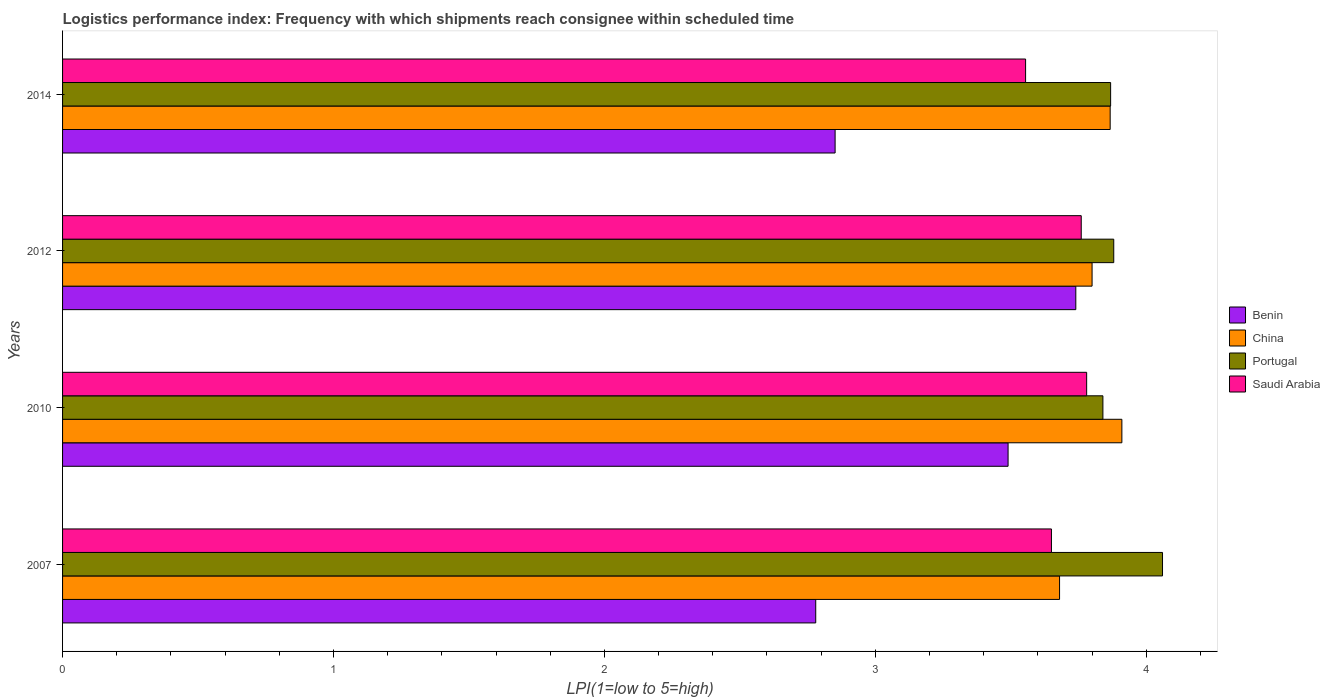How many different coloured bars are there?
Offer a terse response. 4. Are the number of bars per tick equal to the number of legend labels?
Keep it short and to the point. Yes. Are the number of bars on each tick of the Y-axis equal?
Give a very brief answer. Yes. What is the label of the 4th group of bars from the top?
Give a very brief answer. 2007. What is the logistics performance index in Benin in 2012?
Ensure brevity in your answer.  3.74. Across all years, what is the maximum logistics performance index in China?
Offer a very short reply. 3.91. Across all years, what is the minimum logistics performance index in Portugal?
Offer a terse response. 3.84. In which year was the logistics performance index in Portugal maximum?
Your answer should be very brief. 2007. In which year was the logistics performance index in Saudi Arabia minimum?
Your answer should be very brief. 2014. What is the total logistics performance index in Benin in the graph?
Give a very brief answer. 12.86. What is the difference between the logistics performance index in China in 2007 and that in 2014?
Your response must be concise. -0.19. What is the difference between the logistics performance index in Benin in 2010 and the logistics performance index in Saudi Arabia in 2014?
Keep it short and to the point. -0.06. What is the average logistics performance index in Saudi Arabia per year?
Make the answer very short. 3.69. In the year 2010, what is the difference between the logistics performance index in Benin and logistics performance index in Portugal?
Your answer should be very brief. -0.35. In how many years, is the logistics performance index in Benin greater than 1.2 ?
Provide a succinct answer. 4. What is the ratio of the logistics performance index in Saudi Arabia in 2007 to that in 2014?
Offer a terse response. 1.03. Is the logistics performance index in Saudi Arabia in 2010 less than that in 2014?
Offer a very short reply. No. Is the difference between the logistics performance index in Benin in 2010 and 2014 greater than the difference between the logistics performance index in Portugal in 2010 and 2014?
Your response must be concise. Yes. What is the difference between the highest and the second highest logistics performance index in Benin?
Make the answer very short. 0.25. What is the difference between the highest and the lowest logistics performance index in China?
Make the answer very short. 0.23. In how many years, is the logistics performance index in Portugal greater than the average logistics performance index in Portugal taken over all years?
Make the answer very short. 1. What does the 1st bar from the top in 2010 represents?
Your answer should be very brief. Saudi Arabia. What does the 3rd bar from the bottom in 2007 represents?
Make the answer very short. Portugal. How many bars are there?
Offer a terse response. 16. How many years are there in the graph?
Offer a terse response. 4. What is the title of the graph?
Give a very brief answer. Logistics performance index: Frequency with which shipments reach consignee within scheduled time. Does "Estonia" appear as one of the legend labels in the graph?
Your response must be concise. No. What is the label or title of the X-axis?
Give a very brief answer. LPI(1=low to 5=high). What is the label or title of the Y-axis?
Your answer should be compact. Years. What is the LPI(1=low to 5=high) of Benin in 2007?
Offer a terse response. 2.78. What is the LPI(1=low to 5=high) of China in 2007?
Your answer should be very brief. 3.68. What is the LPI(1=low to 5=high) in Portugal in 2007?
Your answer should be very brief. 4.06. What is the LPI(1=low to 5=high) of Saudi Arabia in 2007?
Your answer should be compact. 3.65. What is the LPI(1=low to 5=high) of Benin in 2010?
Provide a succinct answer. 3.49. What is the LPI(1=low to 5=high) in China in 2010?
Ensure brevity in your answer.  3.91. What is the LPI(1=low to 5=high) in Portugal in 2010?
Your answer should be very brief. 3.84. What is the LPI(1=low to 5=high) in Saudi Arabia in 2010?
Provide a succinct answer. 3.78. What is the LPI(1=low to 5=high) of Benin in 2012?
Your response must be concise. 3.74. What is the LPI(1=low to 5=high) of Portugal in 2012?
Give a very brief answer. 3.88. What is the LPI(1=low to 5=high) of Saudi Arabia in 2012?
Offer a terse response. 3.76. What is the LPI(1=low to 5=high) in Benin in 2014?
Keep it short and to the point. 2.85. What is the LPI(1=low to 5=high) in China in 2014?
Give a very brief answer. 3.87. What is the LPI(1=low to 5=high) in Portugal in 2014?
Your answer should be very brief. 3.87. What is the LPI(1=low to 5=high) in Saudi Arabia in 2014?
Your response must be concise. 3.55. Across all years, what is the maximum LPI(1=low to 5=high) of Benin?
Provide a short and direct response. 3.74. Across all years, what is the maximum LPI(1=low to 5=high) in China?
Your answer should be very brief. 3.91. Across all years, what is the maximum LPI(1=low to 5=high) in Portugal?
Your response must be concise. 4.06. Across all years, what is the maximum LPI(1=low to 5=high) in Saudi Arabia?
Ensure brevity in your answer.  3.78. Across all years, what is the minimum LPI(1=low to 5=high) of Benin?
Keep it short and to the point. 2.78. Across all years, what is the minimum LPI(1=low to 5=high) in China?
Offer a terse response. 3.68. Across all years, what is the minimum LPI(1=low to 5=high) of Portugal?
Your response must be concise. 3.84. Across all years, what is the minimum LPI(1=low to 5=high) of Saudi Arabia?
Offer a very short reply. 3.55. What is the total LPI(1=low to 5=high) in Benin in the graph?
Keep it short and to the point. 12.86. What is the total LPI(1=low to 5=high) of China in the graph?
Give a very brief answer. 15.26. What is the total LPI(1=low to 5=high) in Portugal in the graph?
Provide a short and direct response. 15.65. What is the total LPI(1=low to 5=high) of Saudi Arabia in the graph?
Your response must be concise. 14.74. What is the difference between the LPI(1=low to 5=high) in Benin in 2007 and that in 2010?
Provide a succinct answer. -0.71. What is the difference between the LPI(1=low to 5=high) in China in 2007 and that in 2010?
Ensure brevity in your answer.  -0.23. What is the difference between the LPI(1=low to 5=high) of Portugal in 2007 and that in 2010?
Provide a short and direct response. 0.22. What is the difference between the LPI(1=low to 5=high) in Saudi Arabia in 2007 and that in 2010?
Provide a short and direct response. -0.13. What is the difference between the LPI(1=low to 5=high) in Benin in 2007 and that in 2012?
Your response must be concise. -0.96. What is the difference between the LPI(1=low to 5=high) of China in 2007 and that in 2012?
Provide a succinct answer. -0.12. What is the difference between the LPI(1=low to 5=high) in Portugal in 2007 and that in 2012?
Keep it short and to the point. 0.18. What is the difference between the LPI(1=low to 5=high) of Saudi Arabia in 2007 and that in 2012?
Provide a succinct answer. -0.11. What is the difference between the LPI(1=low to 5=high) of Benin in 2007 and that in 2014?
Offer a terse response. -0.07. What is the difference between the LPI(1=low to 5=high) of China in 2007 and that in 2014?
Offer a very short reply. -0.19. What is the difference between the LPI(1=low to 5=high) of Portugal in 2007 and that in 2014?
Offer a very short reply. 0.19. What is the difference between the LPI(1=low to 5=high) in Saudi Arabia in 2007 and that in 2014?
Your answer should be very brief. 0.1. What is the difference between the LPI(1=low to 5=high) of Benin in 2010 and that in 2012?
Your response must be concise. -0.25. What is the difference between the LPI(1=low to 5=high) of China in 2010 and that in 2012?
Give a very brief answer. 0.11. What is the difference between the LPI(1=low to 5=high) in Portugal in 2010 and that in 2012?
Ensure brevity in your answer.  -0.04. What is the difference between the LPI(1=low to 5=high) of Benin in 2010 and that in 2014?
Your answer should be very brief. 0.64. What is the difference between the LPI(1=low to 5=high) of China in 2010 and that in 2014?
Make the answer very short. 0.04. What is the difference between the LPI(1=low to 5=high) of Portugal in 2010 and that in 2014?
Your response must be concise. -0.03. What is the difference between the LPI(1=low to 5=high) in Saudi Arabia in 2010 and that in 2014?
Provide a succinct answer. 0.23. What is the difference between the LPI(1=low to 5=high) of Benin in 2012 and that in 2014?
Ensure brevity in your answer.  0.89. What is the difference between the LPI(1=low to 5=high) in China in 2012 and that in 2014?
Make the answer very short. -0.07. What is the difference between the LPI(1=low to 5=high) in Portugal in 2012 and that in 2014?
Your answer should be compact. 0.01. What is the difference between the LPI(1=low to 5=high) of Saudi Arabia in 2012 and that in 2014?
Make the answer very short. 0.21. What is the difference between the LPI(1=low to 5=high) in Benin in 2007 and the LPI(1=low to 5=high) in China in 2010?
Provide a short and direct response. -1.13. What is the difference between the LPI(1=low to 5=high) in Benin in 2007 and the LPI(1=low to 5=high) in Portugal in 2010?
Offer a terse response. -1.06. What is the difference between the LPI(1=low to 5=high) of China in 2007 and the LPI(1=low to 5=high) of Portugal in 2010?
Your response must be concise. -0.16. What is the difference between the LPI(1=low to 5=high) of China in 2007 and the LPI(1=low to 5=high) of Saudi Arabia in 2010?
Offer a terse response. -0.1. What is the difference between the LPI(1=low to 5=high) of Portugal in 2007 and the LPI(1=low to 5=high) of Saudi Arabia in 2010?
Your response must be concise. 0.28. What is the difference between the LPI(1=low to 5=high) in Benin in 2007 and the LPI(1=low to 5=high) in China in 2012?
Ensure brevity in your answer.  -1.02. What is the difference between the LPI(1=low to 5=high) of Benin in 2007 and the LPI(1=low to 5=high) of Saudi Arabia in 2012?
Provide a succinct answer. -0.98. What is the difference between the LPI(1=low to 5=high) of China in 2007 and the LPI(1=low to 5=high) of Portugal in 2012?
Provide a short and direct response. -0.2. What is the difference between the LPI(1=low to 5=high) of China in 2007 and the LPI(1=low to 5=high) of Saudi Arabia in 2012?
Offer a terse response. -0.08. What is the difference between the LPI(1=low to 5=high) of Benin in 2007 and the LPI(1=low to 5=high) of China in 2014?
Give a very brief answer. -1.09. What is the difference between the LPI(1=low to 5=high) of Benin in 2007 and the LPI(1=low to 5=high) of Portugal in 2014?
Your response must be concise. -1.09. What is the difference between the LPI(1=low to 5=high) in Benin in 2007 and the LPI(1=low to 5=high) in Saudi Arabia in 2014?
Keep it short and to the point. -0.77. What is the difference between the LPI(1=low to 5=high) of China in 2007 and the LPI(1=low to 5=high) of Portugal in 2014?
Offer a terse response. -0.19. What is the difference between the LPI(1=low to 5=high) of China in 2007 and the LPI(1=low to 5=high) of Saudi Arabia in 2014?
Make the answer very short. 0.13. What is the difference between the LPI(1=low to 5=high) of Portugal in 2007 and the LPI(1=low to 5=high) of Saudi Arabia in 2014?
Ensure brevity in your answer.  0.51. What is the difference between the LPI(1=low to 5=high) of Benin in 2010 and the LPI(1=low to 5=high) of China in 2012?
Offer a terse response. -0.31. What is the difference between the LPI(1=low to 5=high) of Benin in 2010 and the LPI(1=low to 5=high) of Portugal in 2012?
Offer a terse response. -0.39. What is the difference between the LPI(1=low to 5=high) of Benin in 2010 and the LPI(1=low to 5=high) of Saudi Arabia in 2012?
Ensure brevity in your answer.  -0.27. What is the difference between the LPI(1=low to 5=high) in Benin in 2010 and the LPI(1=low to 5=high) in China in 2014?
Ensure brevity in your answer.  -0.38. What is the difference between the LPI(1=low to 5=high) of Benin in 2010 and the LPI(1=low to 5=high) of Portugal in 2014?
Offer a terse response. -0.38. What is the difference between the LPI(1=low to 5=high) of Benin in 2010 and the LPI(1=low to 5=high) of Saudi Arabia in 2014?
Offer a very short reply. -0.06. What is the difference between the LPI(1=low to 5=high) in China in 2010 and the LPI(1=low to 5=high) in Portugal in 2014?
Provide a short and direct response. 0.04. What is the difference between the LPI(1=low to 5=high) of China in 2010 and the LPI(1=low to 5=high) of Saudi Arabia in 2014?
Your response must be concise. 0.36. What is the difference between the LPI(1=low to 5=high) in Portugal in 2010 and the LPI(1=low to 5=high) in Saudi Arabia in 2014?
Your response must be concise. 0.29. What is the difference between the LPI(1=low to 5=high) of Benin in 2012 and the LPI(1=low to 5=high) of China in 2014?
Offer a terse response. -0.13. What is the difference between the LPI(1=low to 5=high) in Benin in 2012 and the LPI(1=low to 5=high) in Portugal in 2014?
Provide a short and direct response. -0.13. What is the difference between the LPI(1=low to 5=high) of Benin in 2012 and the LPI(1=low to 5=high) of Saudi Arabia in 2014?
Your response must be concise. 0.19. What is the difference between the LPI(1=low to 5=high) of China in 2012 and the LPI(1=low to 5=high) of Portugal in 2014?
Ensure brevity in your answer.  -0.07. What is the difference between the LPI(1=low to 5=high) in China in 2012 and the LPI(1=low to 5=high) in Saudi Arabia in 2014?
Keep it short and to the point. 0.25. What is the difference between the LPI(1=low to 5=high) of Portugal in 2012 and the LPI(1=low to 5=high) of Saudi Arabia in 2014?
Offer a terse response. 0.33. What is the average LPI(1=low to 5=high) in Benin per year?
Keep it short and to the point. 3.22. What is the average LPI(1=low to 5=high) in China per year?
Offer a terse response. 3.81. What is the average LPI(1=low to 5=high) in Portugal per year?
Keep it short and to the point. 3.91. What is the average LPI(1=low to 5=high) in Saudi Arabia per year?
Your response must be concise. 3.69. In the year 2007, what is the difference between the LPI(1=low to 5=high) in Benin and LPI(1=low to 5=high) in Portugal?
Provide a short and direct response. -1.28. In the year 2007, what is the difference between the LPI(1=low to 5=high) in Benin and LPI(1=low to 5=high) in Saudi Arabia?
Your response must be concise. -0.87. In the year 2007, what is the difference between the LPI(1=low to 5=high) of China and LPI(1=low to 5=high) of Portugal?
Offer a terse response. -0.38. In the year 2007, what is the difference between the LPI(1=low to 5=high) in China and LPI(1=low to 5=high) in Saudi Arabia?
Make the answer very short. 0.03. In the year 2007, what is the difference between the LPI(1=low to 5=high) in Portugal and LPI(1=low to 5=high) in Saudi Arabia?
Give a very brief answer. 0.41. In the year 2010, what is the difference between the LPI(1=low to 5=high) in Benin and LPI(1=low to 5=high) in China?
Keep it short and to the point. -0.42. In the year 2010, what is the difference between the LPI(1=low to 5=high) of Benin and LPI(1=low to 5=high) of Portugal?
Your response must be concise. -0.35. In the year 2010, what is the difference between the LPI(1=low to 5=high) of Benin and LPI(1=low to 5=high) of Saudi Arabia?
Provide a succinct answer. -0.29. In the year 2010, what is the difference between the LPI(1=low to 5=high) in China and LPI(1=low to 5=high) in Portugal?
Provide a succinct answer. 0.07. In the year 2010, what is the difference between the LPI(1=low to 5=high) of China and LPI(1=low to 5=high) of Saudi Arabia?
Keep it short and to the point. 0.13. In the year 2012, what is the difference between the LPI(1=low to 5=high) of Benin and LPI(1=low to 5=high) of China?
Provide a short and direct response. -0.06. In the year 2012, what is the difference between the LPI(1=low to 5=high) of Benin and LPI(1=low to 5=high) of Portugal?
Give a very brief answer. -0.14. In the year 2012, what is the difference between the LPI(1=low to 5=high) in Benin and LPI(1=low to 5=high) in Saudi Arabia?
Make the answer very short. -0.02. In the year 2012, what is the difference between the LPI(1=low to 5=high) in China and LPI(1=low to 5=high) in Portugal?
Ensure brevity in your answer.  -0.08. In the year 2012, what is the difference between the LPI(1=low to 5=high) of Portugal and LPI(1=low to 5=high) of Saudi Arabia?
Your response must be concise. 0.12. In the year 2014, what is the difference between the LPI(1=low to 5=high) of Benin and LPI(1=low to 5=high) of China?
Offer a terse response. -1.02. In the year 2014, what is the difference between the LPI(1=low to 5=high) in Benin and LPI(1=low to 5=high) in Portugal?
Offer a terse response. -1.02. In the year 2014, what is the difference between the LPI(1=low to 5=high) in Benin and LPI(1=low to 5=high) in Saudi Arabia?
Your answer should be compact. -0.7. In the year 2014, what is the difference between the LPI(1=low to 5=high) of China and LPI(1=low to 5=high) of Portugal?
Provide a succinct answer. -0. In the year 2014, what is the difference between the LPI(1=low to 5=high) in China and LPI(1=low to 5=high) in Saudi Arabia?
Provide a succinct answer. 0.31. In the year 2014, what is the difference between the LPI(1=low to 5=high) of Portugal and LPI(1=low to 5=high) of Saudi Arabia?
Make the answer very short. 0.31. What is the ratio of the LPI(1=low to 5=high) of Benin in 2007 to that in 2010?
Provide a succinct answer. 0.8. What is the ratio of the LPI(1=low to 5=high) in Portugal in 2007 to that in 2010?
Provide a succinct answer. 1.06. What is the ratio of the LPI(1=low to 5=high) in Saudi Arabia in 2007 to that in 2010?
Make the answer very short. 0.97. What is the ratio of the LPI(1=low to 5=high) in Benin in 2007 to that in 2012?
Offer a terse response. 0.74. What is the ratio of the LPI(1=low to 5=high) of China in 2007 to that in 2012?
Make the answer very short. 0.97. What is the ratio of the LPI(1=low to 5=high) in Portugal in 2007 to that in 2012?
Ensure brevity in your answer.  1.05. What is the ratio of the LPI(1=low to 5=high) in Saudi Arabia in 2007 to that in 2012?
Provide a succinct answer. 0.97. What is the ratio of the LPI(1=low to 5=high) in Benin in 2007 to that in 2014?
Make the answer very short. 0.97. What is the ratio of the LPI(1=low to 5=high) in China in 2007 to that in 2014?
Make the answer very short. 0.95. What is the ratio of the LPI(1=low to 5=high) of Portugal in 2007 to that in 2014?
Make the answer very short. 1.05. What is the ratio of the LPI(1=low to 5=high) in Saudi Arabia in 2007 to that in 2014?
Your answer should be very brief. 1.03. What is the ratio of the LPI(1=low to 5=high) of Benin in 2010 to that in 2012?
Your answer should be compact. 0.93. What is the ratio of the LPI(1=low to 5=high) in China in 2010 to that in 2012?
Provide a short and direct response. 1.03. What is the ratio of the LPI(1=low to 5=high) in Portugal in 2010 to that in 2012?
Make the answer very short. 0.99. What is the ratio of the LPI(1=low to 5=high) of Benin in 2010 to that in 2014?
Provide a succinct answer. 1.22. What is the ratio of the LPI(1=low to 5=high) in China in 2010 to that in 2014?
Give a very brief answer. 1.01. What is the ratio of the LPI(1=low to 5=high) of Saudi Arabia in 2010 to that in 2014?
Your response must be concise. 1.06. What is the ratio of the LPI(1=low to 5=high) of Benin in 2012 to that in 2014?
Your answer should be very brief. 1.31. What is the ratio of the LPI(1=low to 5=high) of China in 2012 to that in 2014?
Your answer should be compact. 0.98. What is the ratio of the LPI(1=low to 5=high) of Saudi Arabia in 2012 to that in 2014?
Your response must be concise. 1.06. What is the difference between the highest and the second highest LPI(1=low to 5=high) of China?
Offer a terse response. 0.04. What is the difference between the highest and the second highest LPI(1=low to 5=high) in Portugal?
Your response must be concise. 0.18. What is the difference between the highest and the second highest LPI(1=low to 5=high) in Saudi Arabia?
Provide a succinct answer. 0.02. What is the difference between the highest and the lowest LPI(1=low to 5=high) of China?
Give a very brief answer. 0.23. What is the difference between the highest and the lowest LPI(1=low to 5=high) in Portugal?
Your answer should be very brief. 0.22. What is the difference between the highest and the lowest LPI(1=low to 5=high) of Saudi Arabia?
Provide a succinct answer. 0.23. 